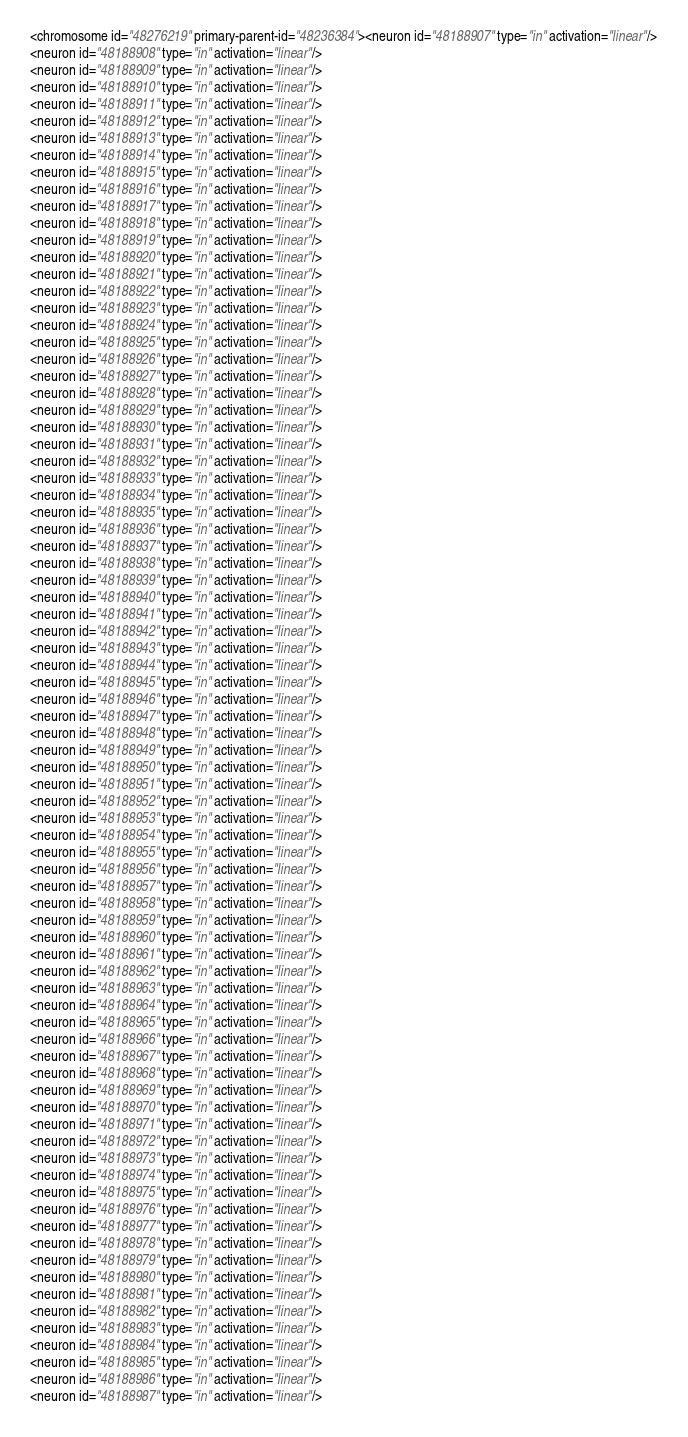<code> <loc_0><loc_0><loc_500><loc_500><_XML_><chromosome id="48276219" primary-parent-id="48236384"><neuron id="48188907" type="in" activation="linear"/>
<neuron id="48188908" type="in" activation="linear"/>
<neuron id="48188909" type="in" activation="linear"/>
<neuron id="48188910" type="in" activation="linear"/>
<neuron id="48188911" type="in" activation="linear"/>
<neuron id="48188912" type="in" activation="linear"/>
<neuron id="48188913" type="in" activation="linear"/>
<neuron id="48188914" type="in" activation="linear"/>
<neuron id="48188915" type="in" activation="linear"/>
<neuron id="48188916" type="in" activation="linear"/>
<neuron id="48188917" type="in" activation="linear"/>
<neuron id="48188918" type="in" activation="linear"/>
<neuron id="48188919" type="in" activation="linear"/>
<neuron id="48188920" type="in" activation="linear"/>
<neuron id="48188921" type="in" activation="linear"/>
<neuron id="48188922" type="in" activation="linear"/>
<neuron id="48188923" type="in" activation="linear"/>
<neuron id="48188924" type="in" activation="linear"/>
<neuron id="48188925" type="in" activation="linear"/>
<neuron id="48188926" type="in" activation="linear"/>
<neuron id="48188927" type="in" activation="linear"/>
<neuron id="48188928" type="in" activation="linear"/>
<neuron id="48188929" type="in" activation="linear"/>
<neuron id="48188930" type="in" activation="linear"/>
<neuron id="48188931" type="in" activation="linear"/>
<neuron id="48188932" type="in" activation="linear"/>
<neuron id="48188933" type="in" activation="linear"/>
<neuron id="48188934" type="in" activation="linear"/>
<neuron id="48188935" type="in" activation="linear"/>
<neuron id="48188936" type="in" activation="linear"/>
<neuron id="48188937" type="in" activation="linear"/>
<neuron id="48188938" type="in" activation="linear"/>
<neuron id="48188939" type="in" activation="linear"/>
<neuron id="48188940" type="in" activation="linear"/>
<neuron id="48188941" type="in" activation="linear"/>
<neuron id="48188942" type="in" activation="linear"/>
<neuron id="48188943" type="in" activation="linear"/>
<neuron id="48188944" type="in" activation="linear"/>
<neuron id="48188945" type="in" activation="linear"/>
<neuron id="48188946" type="in" activation="linear"/>
<neuron id="48188947" type="in" activation="linear"/>
<neuron id="48188948" type="in" activation="linear"/>
<neuron id="48188949" type="in" activation="linear"/>
<neuron id="48188950" type="in" activation="linear"/>
<neuron id="48188951" type="in" activation="linear"/>
<neuron id="48188952" type="in" activation="linear"/>
<neuron id="48188953" type="in" activation="linear"/>
<neuron id="48188954" type="in" activation="linear"/>
<neuron id="48188955" type="in" activation="linear"/>
<neuron id="48188956" type="in" activation="linear"/>
<neuron id="48188957" type="in" activation="linear"/>
<neuron id="48188958" type="in" activation="linear"/>
<neuron id="48188959" type="in" activation="linear"/>
<neuron id="48188960" type="in" activation="linear"/>
<neuron id="48188961" type="in" activation="linear"/>
<neuron id="48188962" type="in" activation="linear"/>
<neuron id="48188963" type="in" activation="linear"/>
<neuron id="48188964" type="in" activation="linear"/>
<neuron id="48188965" type="in" activation="linear"/>
<neuron id="48188966" type="in" activation="linear"/>
<neuron id="48188967" type="in" activation="linear"/>
<neuron id="48188968" type="in" activation="linear"/>
<neuron id="48188969" type="in" activation="linear"/>
<neuron id="48188970" type="in" activation="linear"/>
<neuron id="48188971" type="in" activation="linear"/>
<neuron id="48188972" type="in" activation="linear"/>
<neuron id="48188973" type="in" activation="linear"/>
<neuron id="48188974" type="in" activation="linear"/>
<neuron id="48188975" type="in" activation="linear"/>
<neuron id="48188976" type="in" activation="linear"/>
<neuron id="48188977" type="in" activation="linear"/>
<neuron id="48188978" type="in" activation="linear"/>
<neuron id="48188979" type="in" activation="linear"/>
<neuron id="48188980" type="in" activation="linear"/>
<neuron id="48188981" type="in" activation="linear"/>
<neuron id="48188982" type="in" activation="linear"/>
<neuron id="48188983" type="in" activation="linear"/>
<neuron id="48188984" type="in" activation="linear"/>
<neuron id="48188985" type="in" activation="linear"/>
<neuron id="48188986" type="in" activation="linear"/>
<neuron id="48188987" type="in" activation="linear"/></code> 